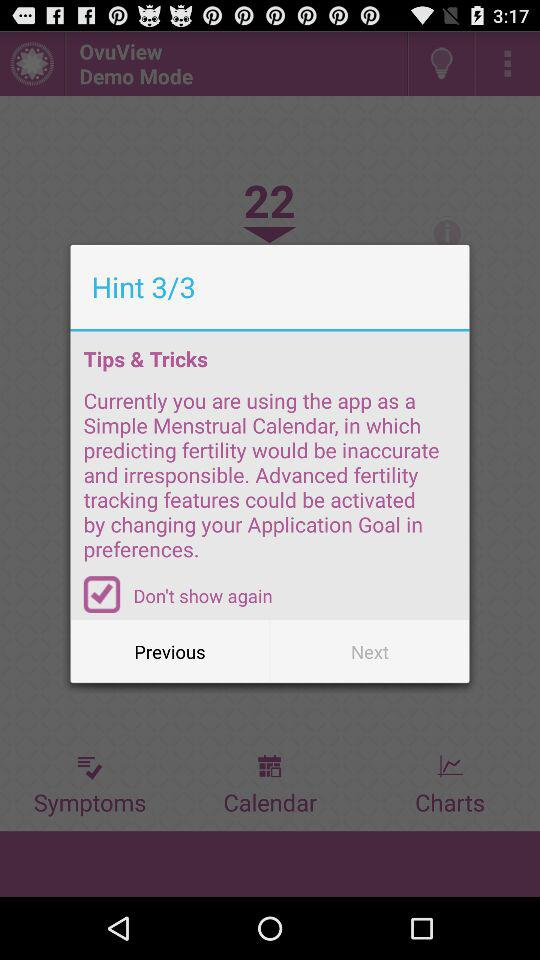Which is the current hint? The current hint is "Currently you are using the app as a Simple Menstrual Calendar, in which predicting fertility would be inaccurate and irresponsible. Advanced fertility tracking features could be activated by changing your Application Goal in preferences". 